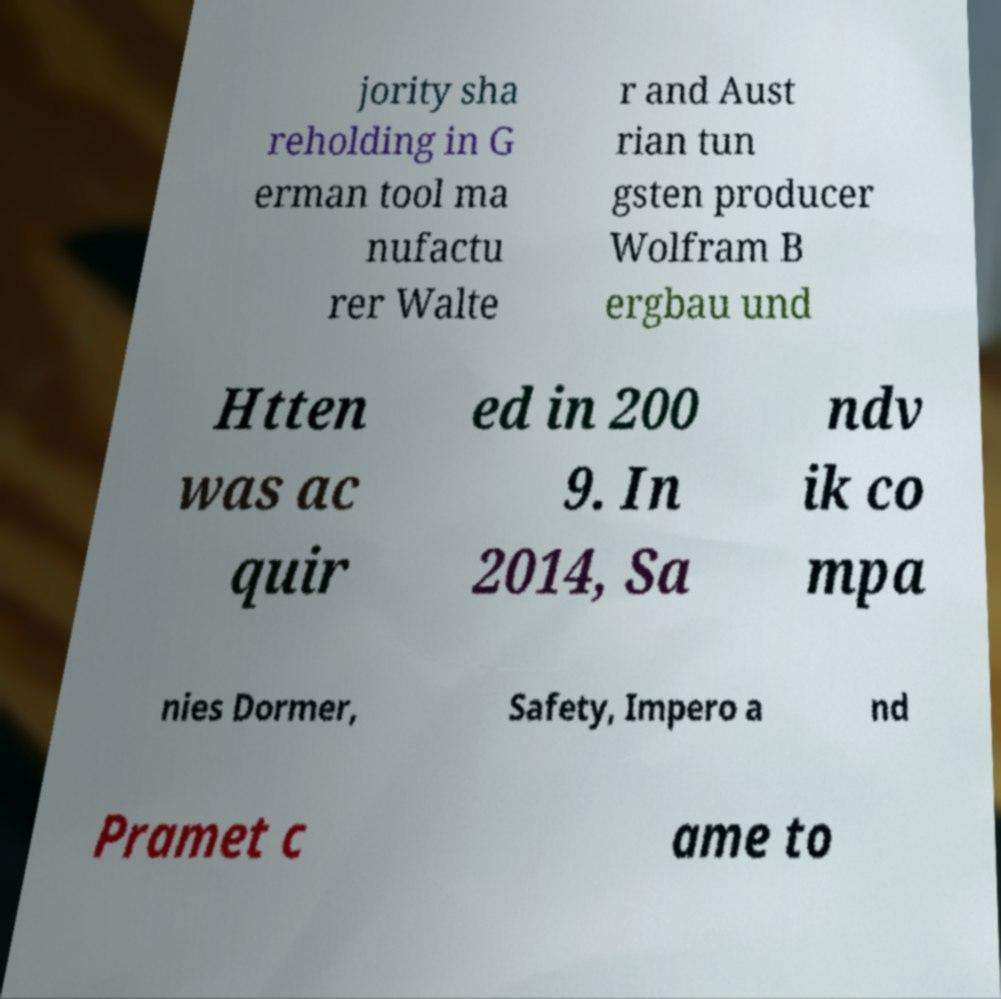Can you accurately transcribe the text from the provided image for me? jority sha reholding in G erman tool ma nufactu rer Walte r and Aust rian tun gsten producer Wolfram B ergbau und Htten was ac quir ed in 200 9. In 2014, Sa ndv ik co mpa nies Dormer, Safety, Impero a nd Pramet c ame to 